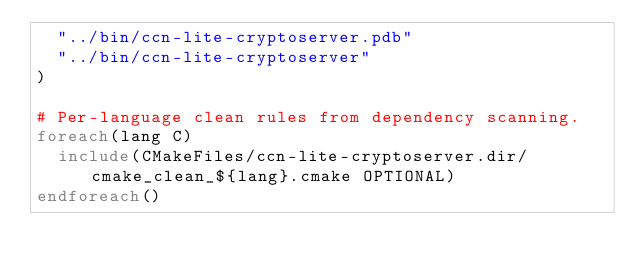<code> <loc_0><loc_0><loc_500><loc_500><_CMake_>  "../bin/ccn-lite-cryptoserver.pdb"
  "../bin/ccn-lite-cryptoserver"
)

# Per-language clean rules from dependency scanning.
foreach(lang C)
  include(CMakeFiles/ccn-lite-cryptoserver.dir/cmake_clean_${lang}.cmake OPTIONAL)
endforeach()
</code> 